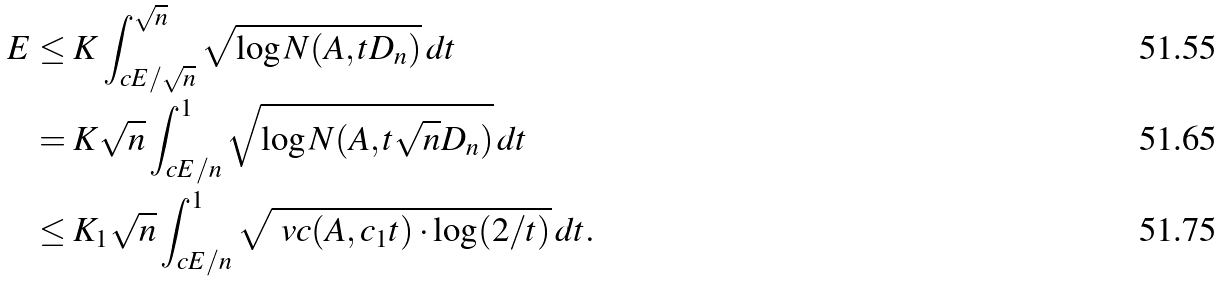<formula> <loc_0><loc_0><loc_500><loc_500>E & \leq K \int _ { c E / \sqrt { n } } ^ { \sqrt { n } } \sqrt { \log N ( A , t D _ { n } ) } \, d t \\ & = K \sqrt { n } \int _ { c E / n } ^ { 1 } \sqrt { \log N ( A , t \sqrt { n } D _ { n } ) } \, d t \\ & \leq K _ { 1 } \sqrt { n } \int _ { c E / n } ^ { 1 } \sqrt { \ v c ( A , c _ { 1 } t ) \cdot \log ( 2 / t ) } \, d t .</formula> 